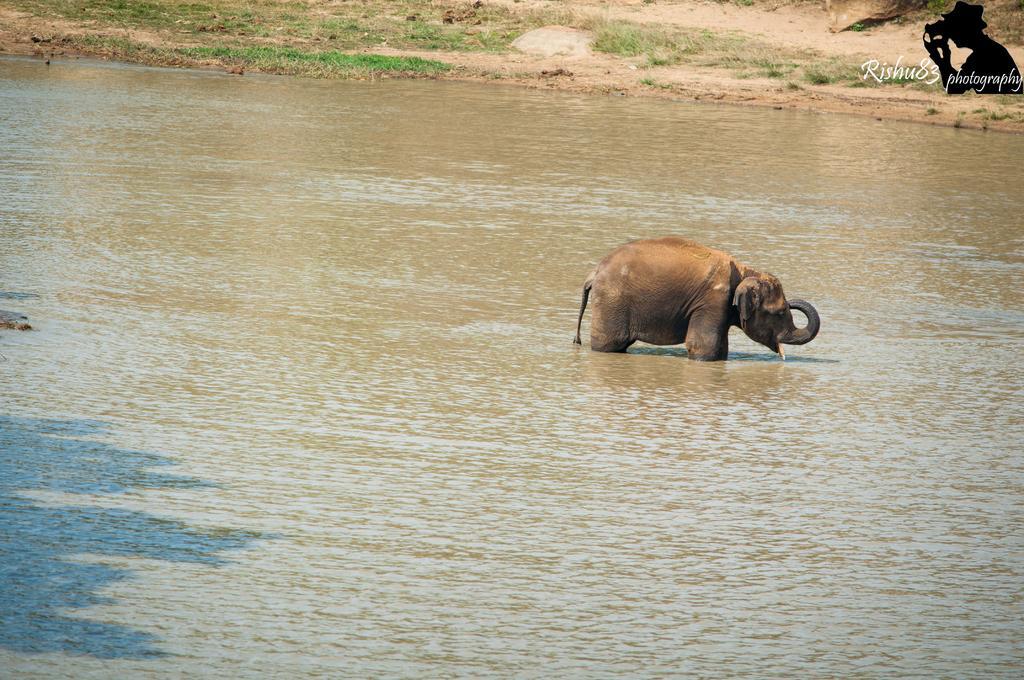Please provide a concise description of this image. In this picture we can see an elephant in the water and we can see grass and ground. In the top right side of the image we can see an image of a person and text. 